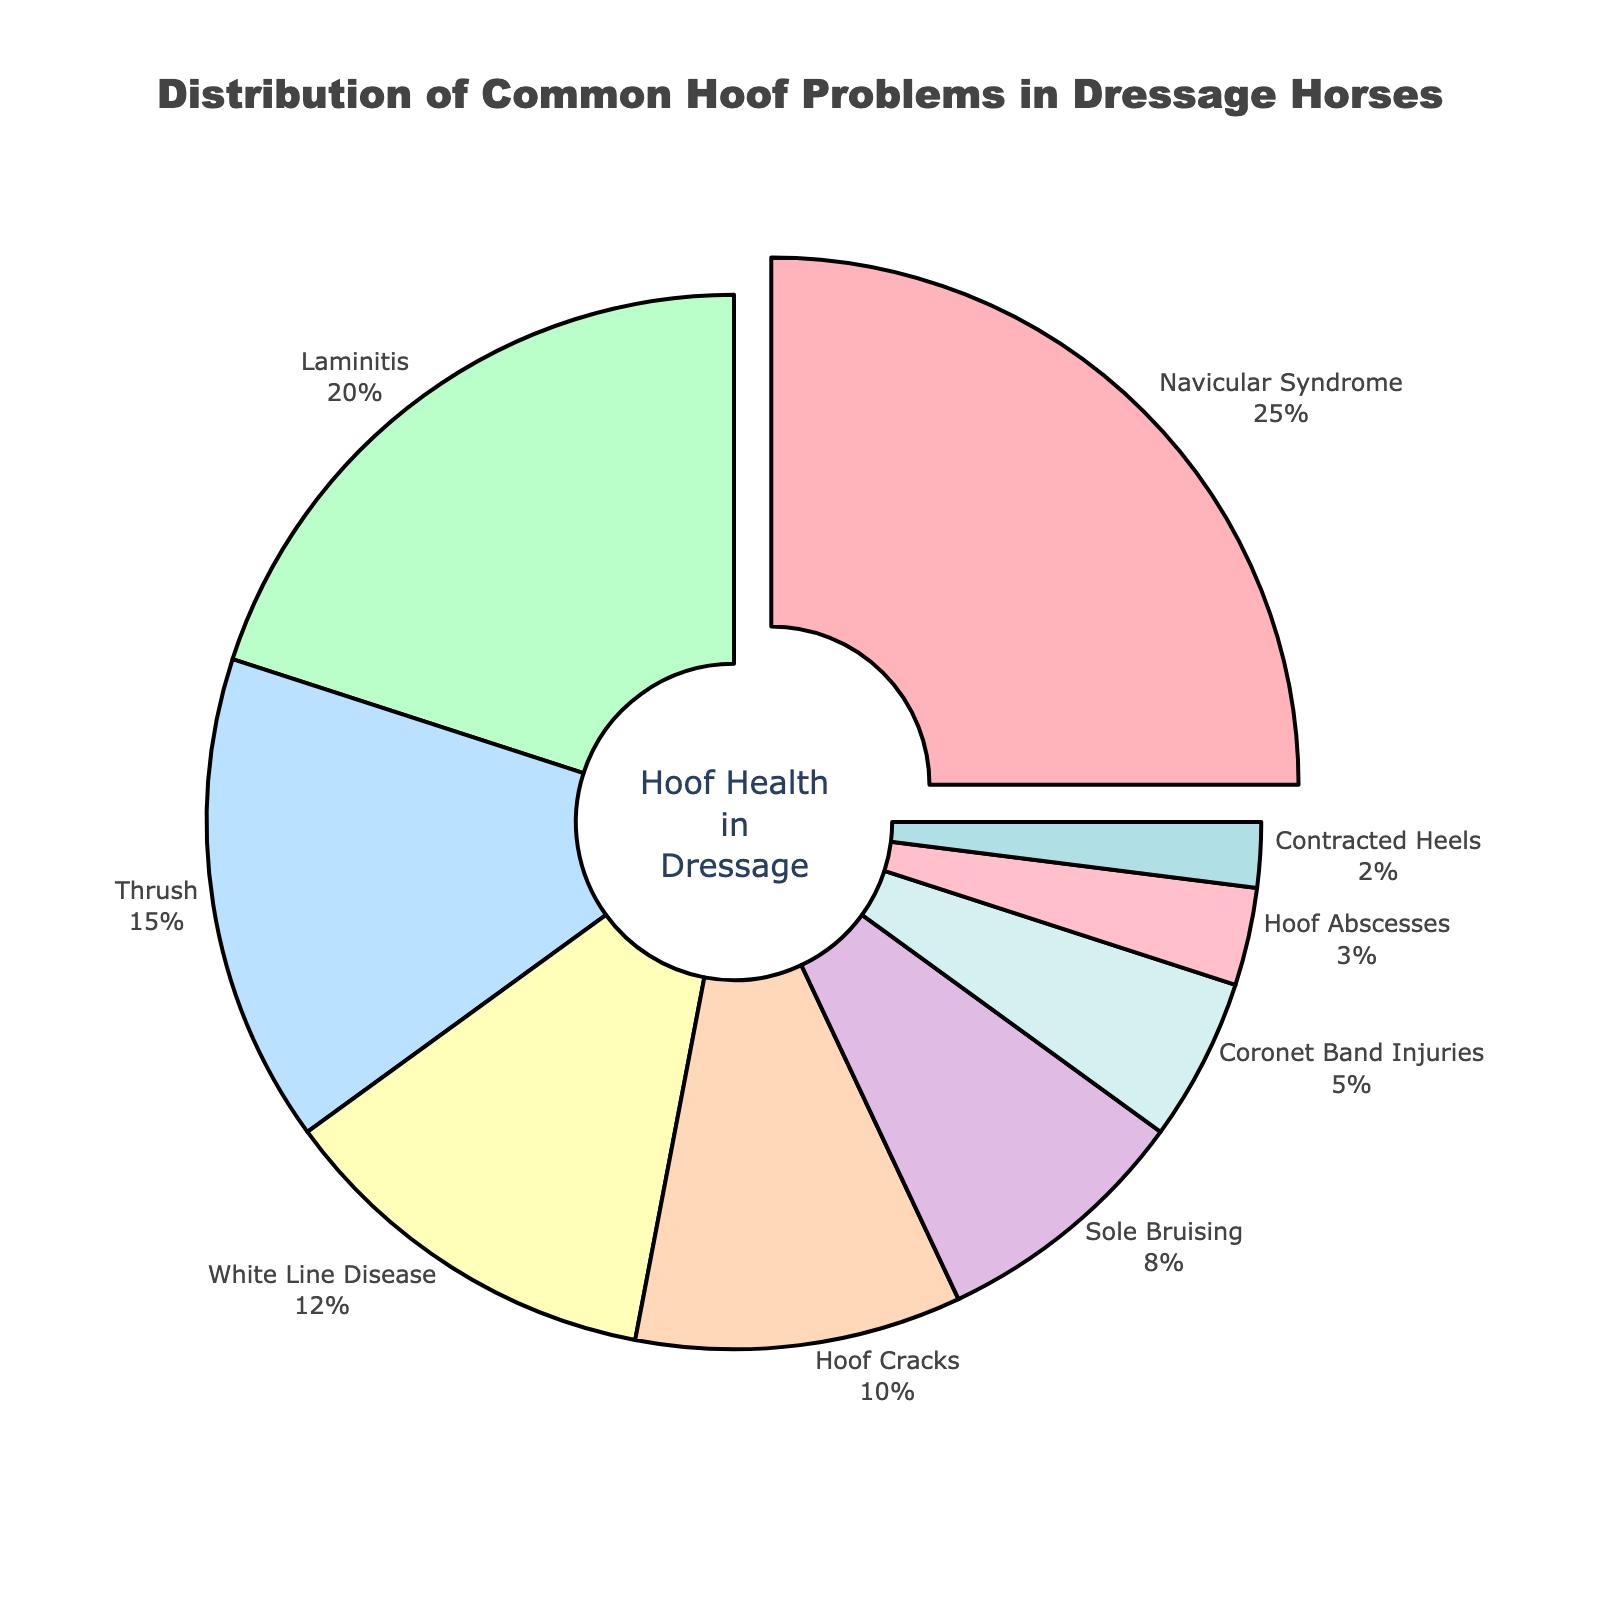What is the most common hoof problem in dressage horses? The largest portion of the pie chart is dedicated to Navicular Syndrome, indicating it has the highest percentage.
Answer: Navicular Syndrome Which hoof problem is more prevalent: Thrush or White Line Disease? Thrush has a higher percentage at 15% compared to White Line Disease at 12%.
Answer: Thrush What percentage of hoof problems is attributed to Laminitis and Hoof Cracks combined? Adding the percentages of Laminitis (20%) and Hoof Cracks (10%), we get 20% + 10% = 30%.
Answer: 30% Are Coronet Band Injuries less common than Sole Bruising? Yes, Coronet Band Injuries make up 5%, whereas Sole Bruising constitutes 8%.
Answer: Yes By how much does the percentage of Navicular Syndrome exceed that of Hoof Abscesses? Navicular Syndrome is 25%, and Hoof Abscesses are 3%. The difference is 25% - 3% = 22%.
Answer: 22% Which problem occupies the smallest segment in the pie chart? Contracted Heels occupies the smallest segment at 2%.
Answer: Contracted Heels What is the cumulative percentage of less common hoof problems (Coronet Band Injuries, Hoof Abscesses, and Contracted Heels)? Summing the percentages of Coronet Band Injuries (5%), Hoof Abscesses (3%), and Contracted Heels (2%) gives us 5% + 3% + 2% = 10%.
Answer: 10% How does the combined percentage of Thrush and White Line Disease compare to Navicular Syndrome? Adding Thrush (15%) and White Line Disease (12%) results in 15% + 12% = 27%, which is slightly higher than Navicular Syndrome's 25%.
Answer: Higher What percentage is allocated to both Sole Bruising and Hoof Cracks together? Adding the percentages for Sole Bruising (8%) and Hoof Cracks (10%), we get 8% + 10% = 18%.
Answer: 18% What fraction of the pie chart is representative of Hoof Abscesses and Contracted Heels together? Adding the percentages of Hoof Abscesses (3%) and Contracted Heels (2%) gives 3% + 2% = 5%, which translates to 5/100 or 1/20 of the pie chart.
Answer: 1/20 